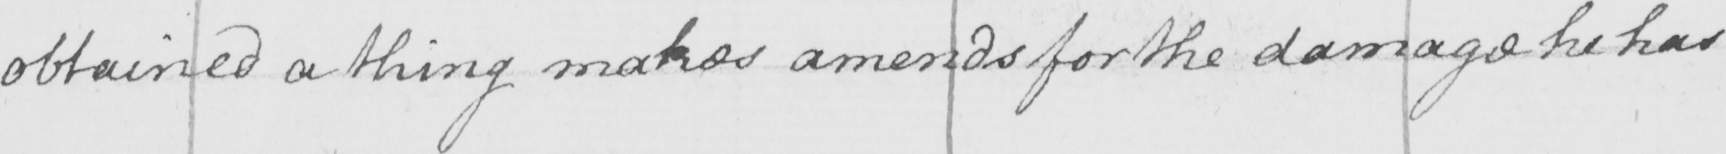Please transcribe the handwritten text in this image. obtained a thing makes amends for the damage he has 